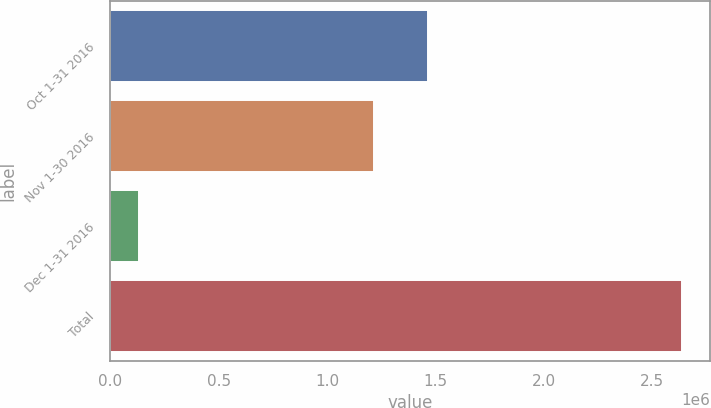Convert chart. <chart><loc_0><loc_0><loc_500><loc_500><bar_chart><fcel>Oct 1-31 2016<fcel>Nov 1-30 2016<fcel>Dec 1-31 2016<fcel>Total<nl><fcel>1.46686e+06<fcel>1.21659e+06<fcel>134469<fcel>2.63719e+06<nl></chart> 